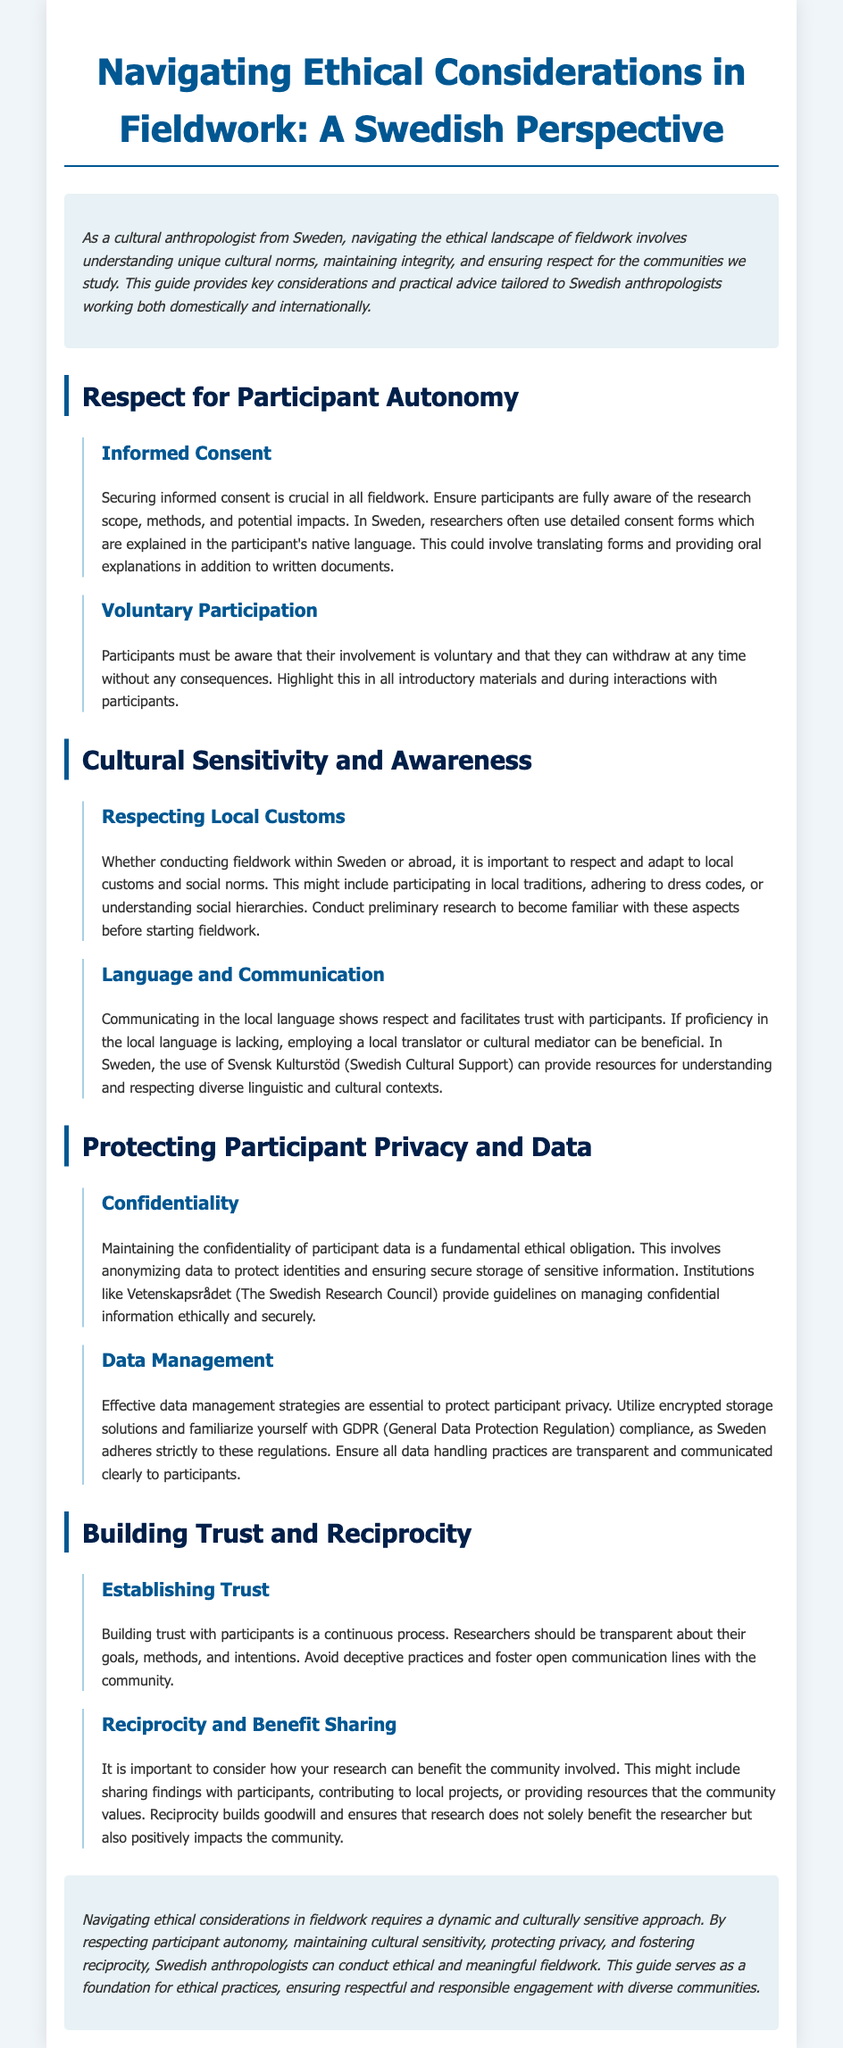what is the main focus of the guide? The main focus is on navigating ethical considerations in fieldwork from a Swedish perspective.
Answer: ethical considerations in fieldwork what is crucial in all fieldwork according to the document? According to the document, securing informed consent is crucial in all fieldwork.
Answer: informed consent which institution provides guidelines on managing confidential information? The document mentions Vetenskapsrådet (The Swedish Research Council) as providing guidelines on managing confidential information.
Answer: Vetenskapsrådet what should participants be aware of regarding their involvement? Participants must be aware that their involvement is voluntary and can withdraw at any time without consequences.
Answer: voluntary involvement what helps in building trust with participants? Building trust with participants involves being transparent about research goals, methods, and intentions.
Answer: transparency what does the document recommend if proficiency in the local language is lacking? The document recommends employing a local translator or cultural mediator if proficiency in the local language is lacking.
Answer: local translator what are effective strategies for protecting participant privacy? Effective data management strategies, such as using encrypted storage solutions, are essential for protecting participant privacy.
Answer: encrypted storage solutions how does the guide suggest researchers can benefit the community involved? Researchers can consider sharing findings with participants, contributing to local projects, or providing resources that the community values.
Answer: sharing findings what is a key ethical obligation mentioned in the document? Maintaining the confidentiality of participant data is a fundamental ethical obligation mentioned in the document.
Answer: confidentiality 